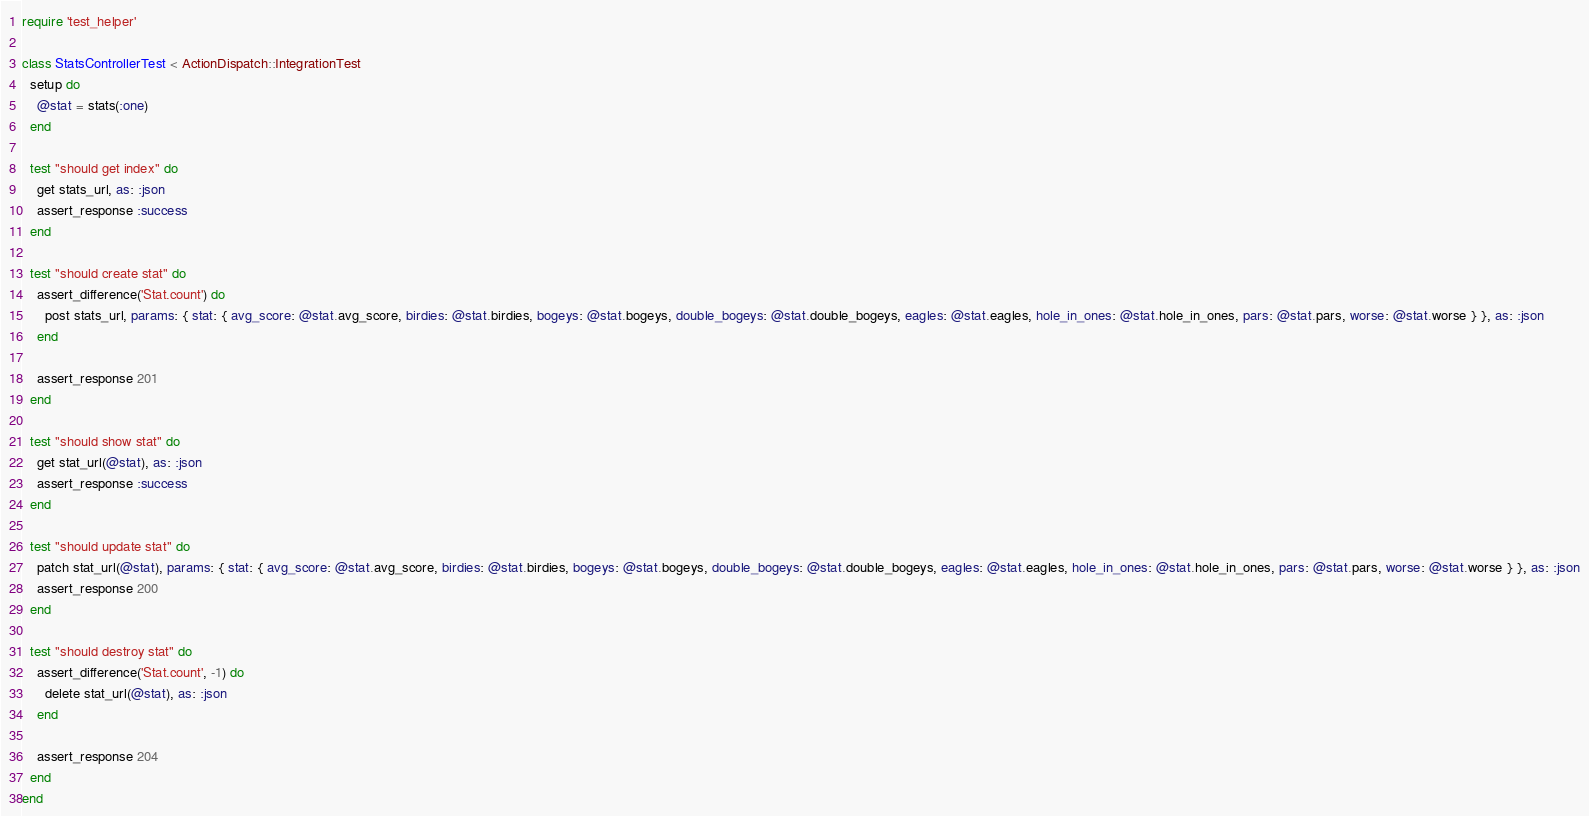<code> <loc_0><loc_0><loc_500><loc_500><_Ruby_>require 'test_helper'

class StatsControllerTest < ActionDispatch::IntegrationTest
  setup do
    @stat = stats(:one)
  end

  test "should get index" do
    get stats_url, as: :json
    assert_response :success
  end

  test "should create stat" do
    assert_difference('Stat.count') do
      post stats_url, params: { stat: { avg_score: @stat.avg_score, birdies: @stat.birdies, bogeys: @stat.bogeys, double_bogeys: @stat.double_bogeys, eagles: @stat.eagles, hole_in_ones: @stat.hole_in_ones, pars: @stat.pars, worse: @stat.worse } }, as: :json
    end

    assert_response 201
  end

  test "should show stat" do
    get stat_url(@stat), as: :json
    assert_response :success
  end

  test "should update stat" do
    patch stat_url(@stat), params: { stat: { avg_score: @stat.avg_score, birdies: @stat.birdies, bogeys: @stat.bogeys, double_bogeys: @stat.double_bogeys, eagles: @stat.eagles, hole_in_ones: @stat.hole_in_ones, pars: @stat.pars, worse: @stat.worse } }, as: :json
    assert_response 200
  end

  test "should destroy stat" do
    assert_difference('Stat.count', -1) do
      delete stat_url(@stat), as: :json
    end

    assert_response 204
  end
end
</code> 